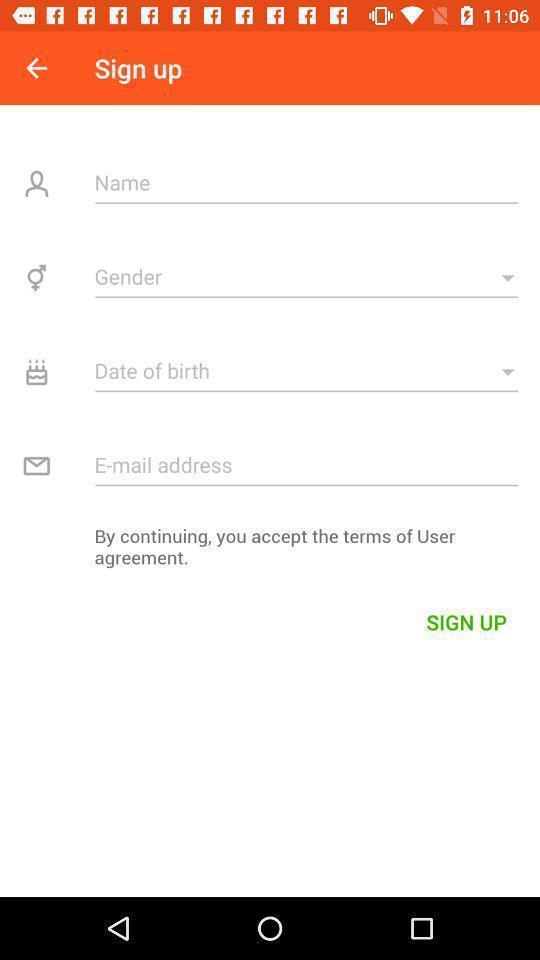Tell me about the visual elements in this screen capture. Sign up page. 